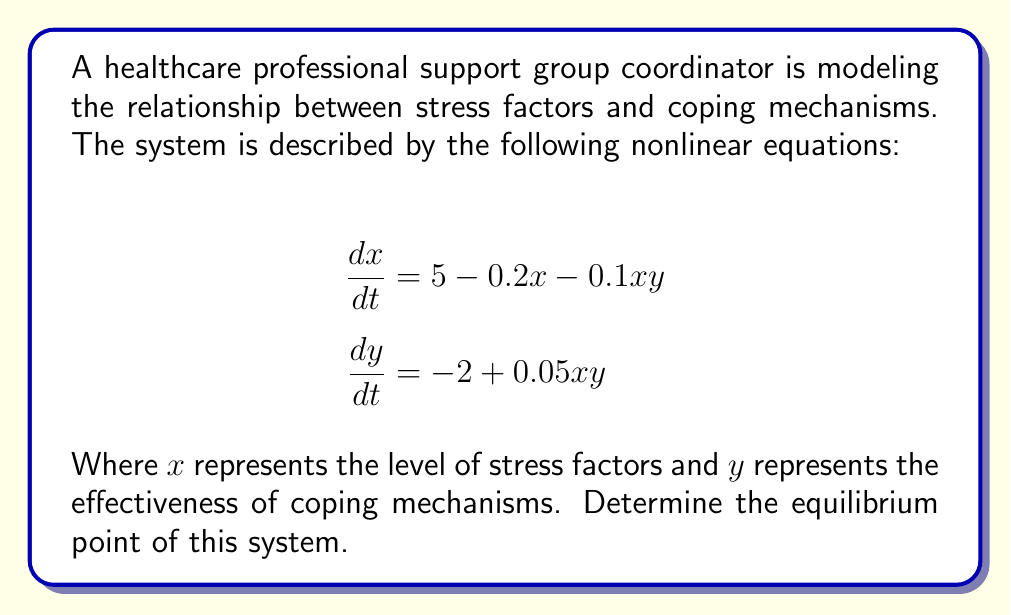Provide a solution to this math problem. To find the equilibrium point, we need to set both equations equal to zero and solve for x and y:

1) Set $\frac{dx}{dt} = 0$ and $\frac{dy}{dt} = 0$:

   $$5 - 0.2x - 0.1xy = 0$$
   $$-2 + 0.05xy = 0$$

2) From the second equation:
   $$0.05xy = 2$$
   $$xy = 40$$

3) Substitute this into the first equation:
   $$5 - 0.2x - 0.1(40) = 0$$
   $$5 - 0.2x - 4 = 0$$
   $$1 - 0.2x = 0$$
   $$0.2x = 1$$
   $$x = 5$$

4) Now that we know $x = 5$, we can find $y$ using $xy = 40$:
   $$5y = 40$$
   $$y = 8$$

5) Therefore, the equilibrium point is (5, 8).

This means that the system will stabilize when the stress factor level is 5 and the coping mechanism effectiveness is 8.
Answer: (5, 8) 